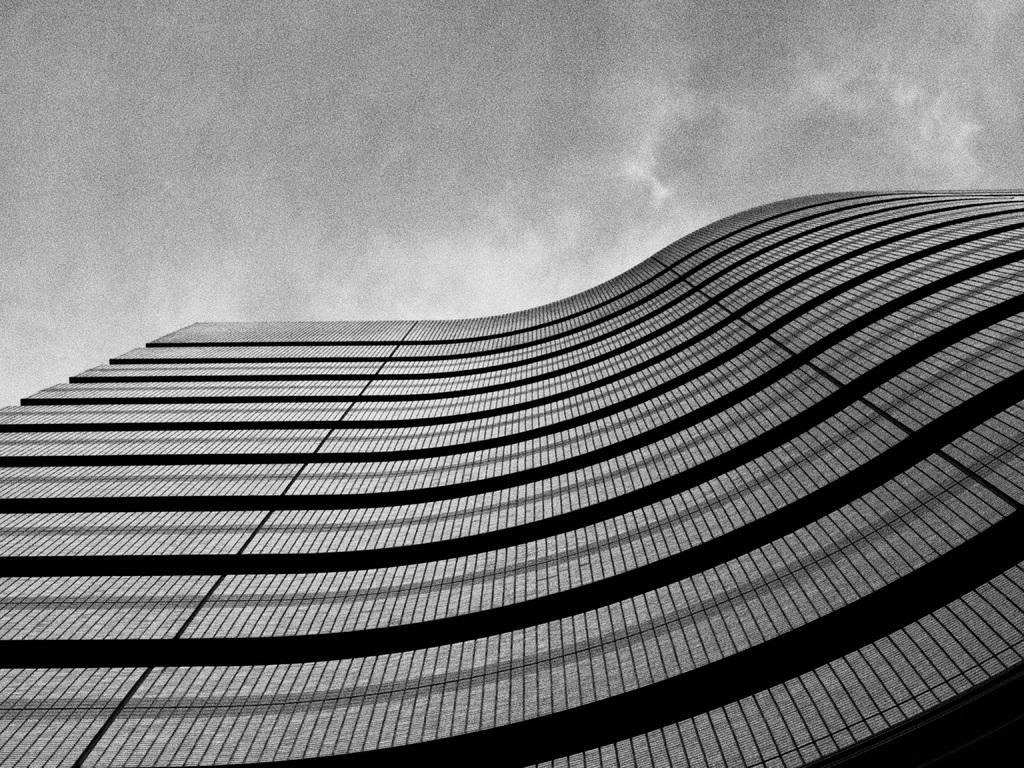What type of photograph is in the image? The image contains a black and white photograph. What is the main subject of the photograph? The main subject of the photograph is a big glass building. What can be seen in the background of the photograph? The sky is visible at the top of the image. What type of rock is being used as a toy in the image? There is no rock or toy present in the image. 